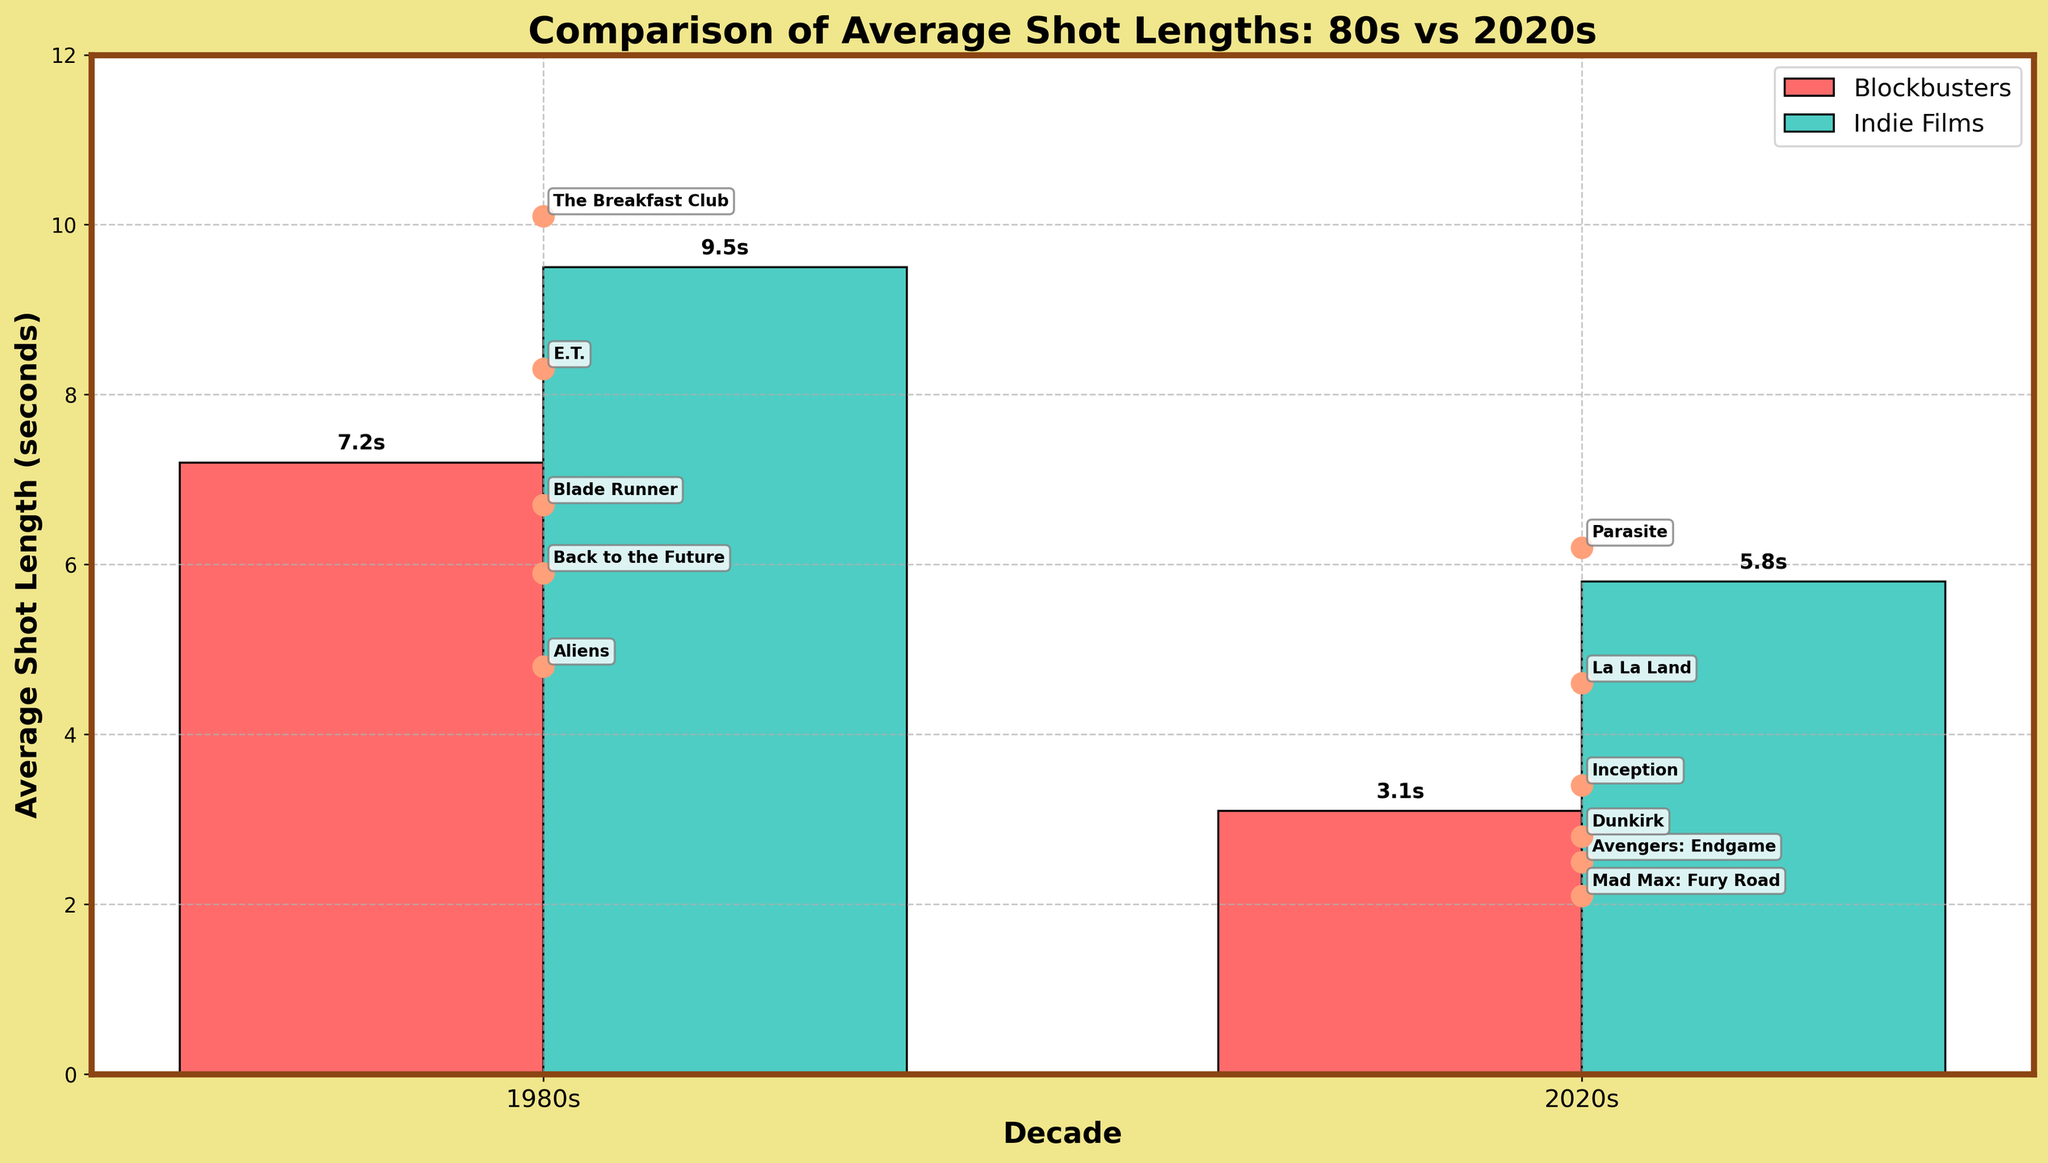Which decade has longer average shot lengths in blockbusters? The figure shows that the average shot length of 1980s blockbusters is higher than that of 2020s blockbusters. Specifically, 1980s blockbusters have an average shot length of 7.2 seconds, while 2020s blockbusters have 3.1 seconds.
Answer: 1980s What is the difference in average shot lengths between 1980s and 2020s indie films? The average shot length for 1980s indie films is 9.5 seconds, and for 2020s indie films, it's 5.8 seconds. Subtracting these two values gives 9.5 - 5.8 = 3.7 seconds.
Answer: 3.7 Which type of film has the shortest average shot length in the 2020s? According to the figure, 2020s blockbusters have the shortest average shot length, which is 3.1 seconds.
Answer: 2020s blockbusters Which film has the longest average shot length among the specific films listed? The figure shows specific films as points on the chart. “The Shining (1980)” has the highest average shot length among specific films at 12.3 seconds.
Answer: The Shining How much shorter is the average shot length of "Mad Max: Fury Road" compared to "Blade Runner"? “Mad Max: Fury Road” has an average shot length of 2.1 seconds, whereas “Blade Runner” has 6.7 seconds. The difference is 6.7 - 2.1 = 4.6 seconds.
Answer: 4.6 What's the average of the average shot lengths for the 1980s blockbusters and indie films? For 1980s blockbusters, it’s 7.2 seconds; for 1980s indie films, it’s 9.5 seconds. The average is (7.2 + 9.5) / 2 = 8.35 seconds.
Answer: 8.35 Which has a greater average shot length, "E.T. (1982)" or "Inception (2010)"? The figure shows that "E.T. (1982)" has an average shot length of 8.3 seconds, while "Inception (2010)" has 3.4 seconds. Since 8.3 is greater than 3.4, "E.T. (1982)" has a greater average shot length.
Answer: E.T. (1982) How many seconds difference is there between the longest and shortest average shot lengths among the specific films in the 2020s? In the 2020s, "Parasite (2019)" has the longest average shot length at 6.2 seconds, and "Mad Max: Fury Road (2015)" has the shortest at 2.1 seconds. The difference is 6.2 - 2.1 = 4.1 seconds.
Answer: 4.1 What color represents indie films in the bar chart? By examining the bar chart, indie films are represented by the green bars.
Answer: Green 